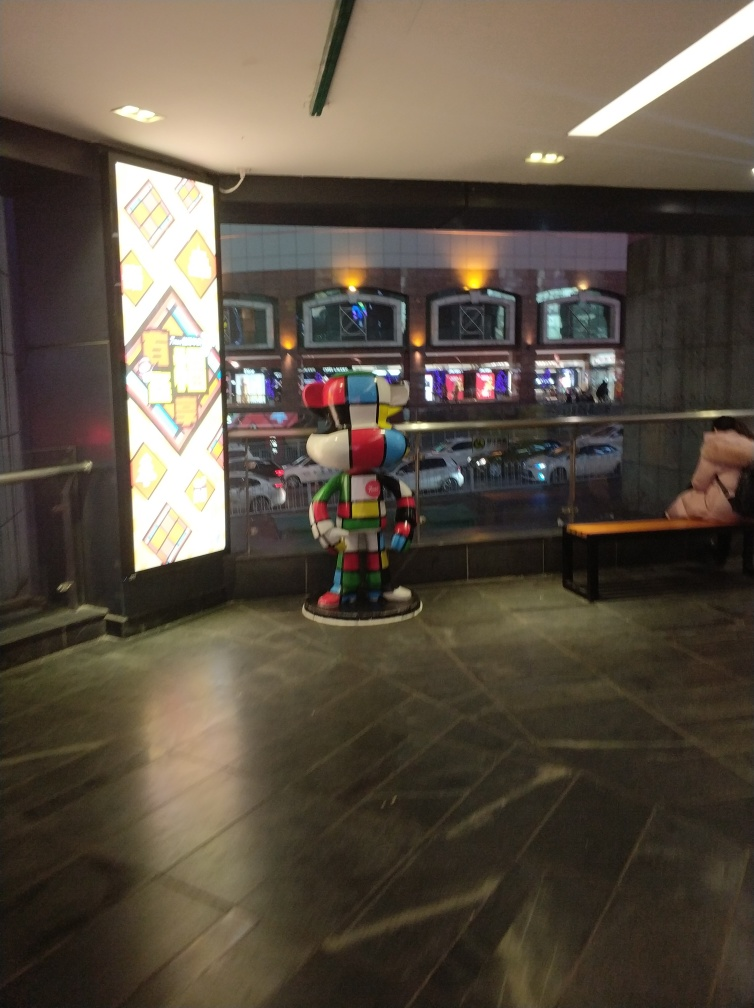Can you tell me about the figure in the foreground? Certainly! The figure appears to be a colorful sculpture, designed with segmented sections in various hues that create a patchwork effect. It's an example of contemporary art, possibly serving as a decorative element within the space it occupies. Does the sculpture represent any recognizable character or is it purely abstract? The sculpture does not seem to represent a specific character; it seems to be an abstract piece. Its focus on color and form over representing a real-life object is typical of abstract art. 